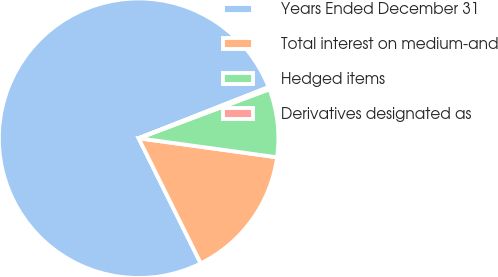Convert chart to OTSL. <chart><loc_0><loc_0><loc_500><loc_500><pie_chart><fcel>Years Ended December 31<fcel>Total interest on medium-and<fcel>Hedged items<fcel>Derivatives designated as<nl><fcel>76.37%<fcel>15.49%<fcel>7.88%<fcel>0.26%<nl></chart> 